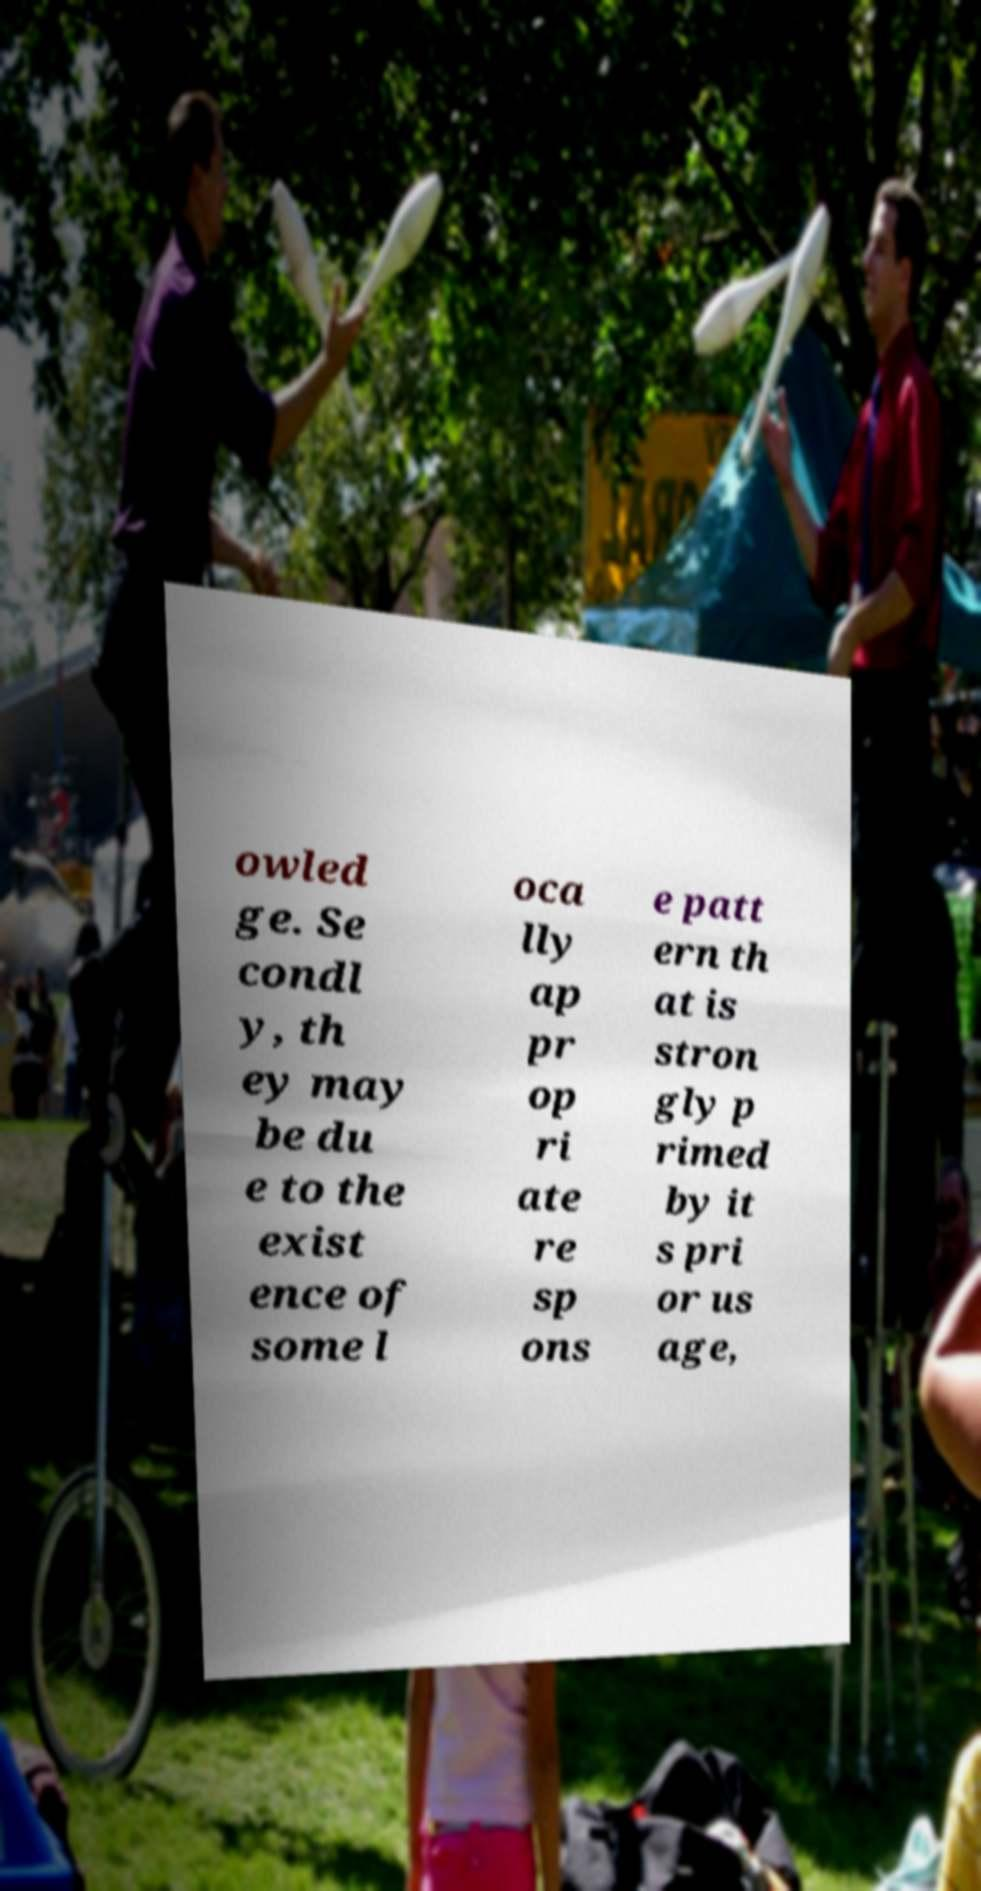Please identify and transcribe the text found in this image. owled ge. Se condl y, th ey may be du e to the exist ence of some l oca lly ap pr op ri ate re sp ons e patt ern th at is stron gly p rimed by it s pri or us age, 